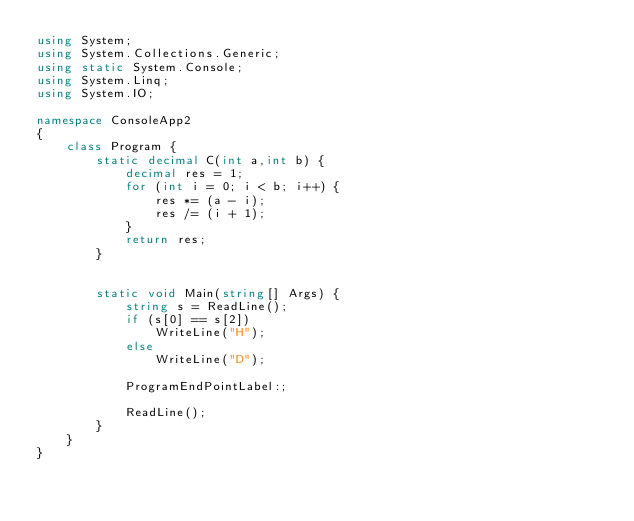Convert code to text. <code><loc_0><loc_0><loc_500><loc_500><_C#_>using System;
using System.Collections.Generic;
using static System.Console;
using System.Linq;
using System.IO;

namespace ConsoleApp2
{
    class Program {
        static decimal C(int a,int b) {
            decimal res = 1;
            for (int i = 0; i < b; i++) {
                res *= (a - i);
                res /= (i + 1);
            }
            return res;
        }


        static void Main(string[] Args) {
            string s = ReadLine();
            if (s[0] == s[2])
                WriteLine("H");
            else
                WriteLine("D");

            ProgramEndPointLabel:;

            ReadLine();
        }
    }
}
</code> 